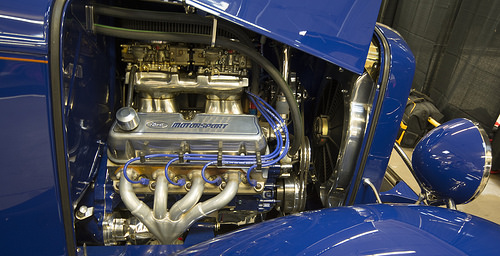<image>
Is the car behind the bag? No. The car is not behind the bag. From this viewpoint, the car appears to be positioned elsewhere in the scene. 